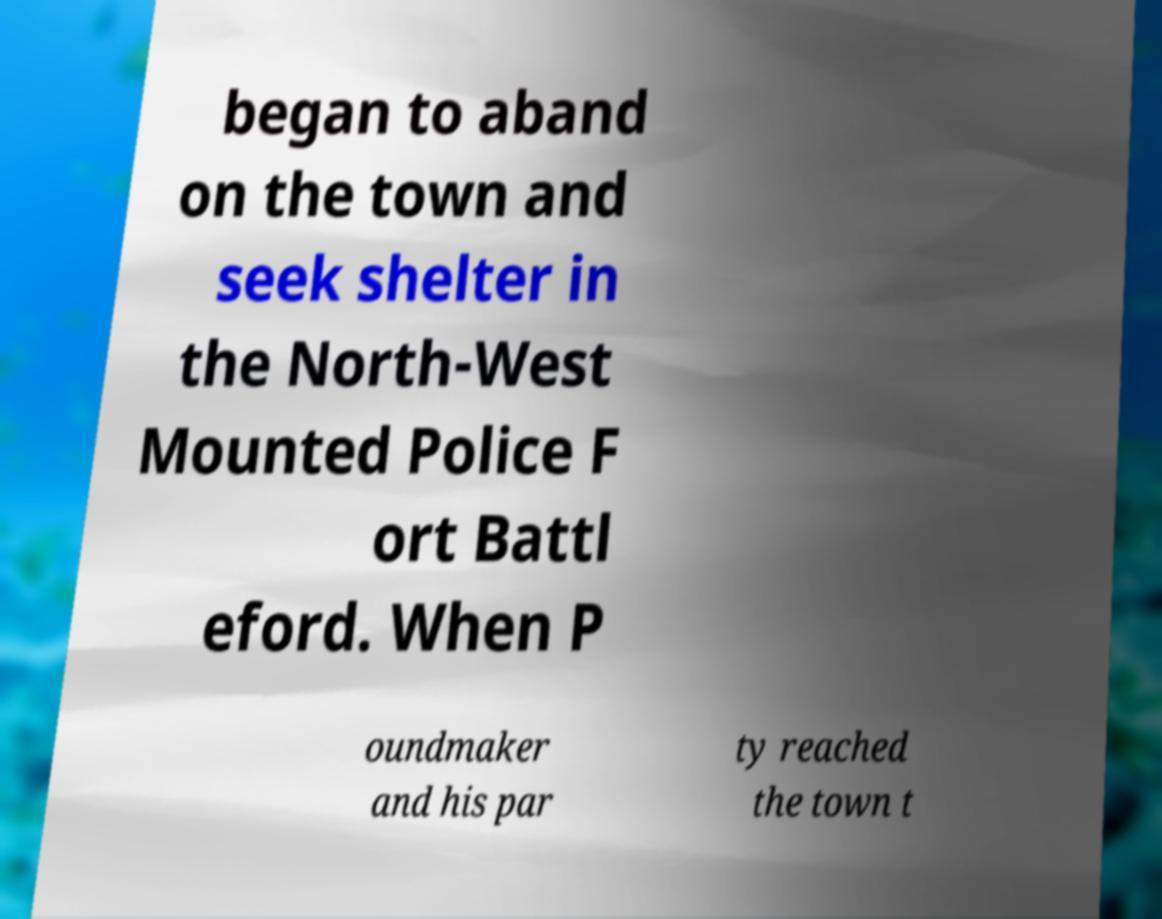Can you accurately transcribe the text from the provided image for me? began to aband on the town and seek shelter in the North-West Mounted Police F ort Battl eford. When P oundmaker and his par ty reached the town t 